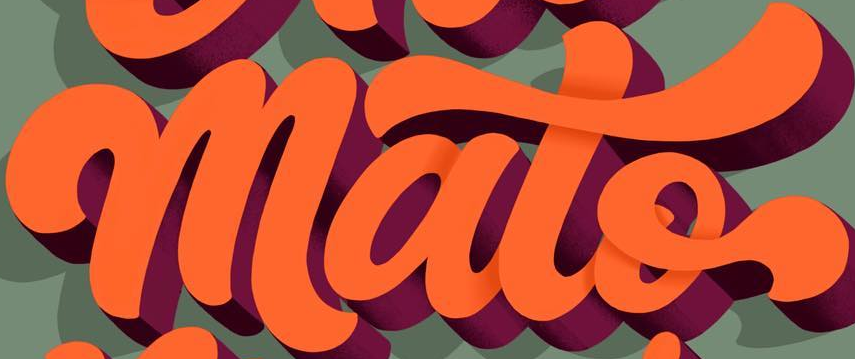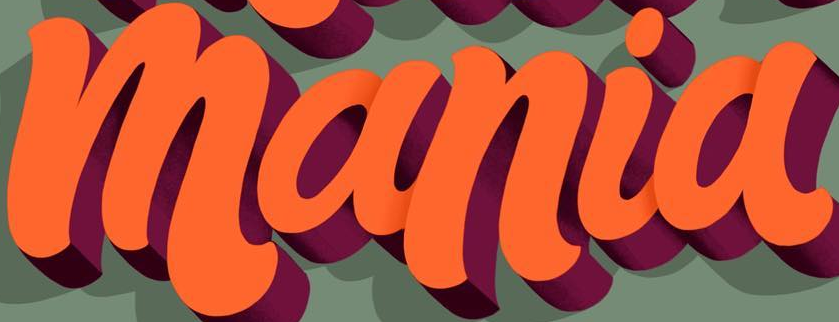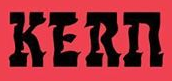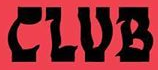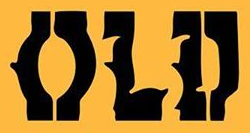What text is displayed in these images sequentially, separated by a semicolon? mato; mania; KERn; CLUB; OLD 